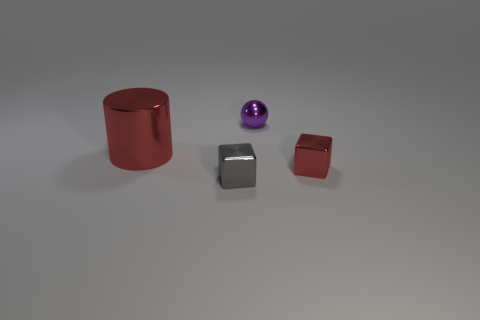Add 2 small yellow balls. How many objects exist? 6 Subtract all spheres. How many objects are left? 3 Add 4 large red things. How many large red things exist? 5 Subtract 0 blue blocks. How many objects are left? 4 Subtract all tiny purple objects. Subtract all tiny red shiny cubes. How many objects are left? 2 Add 1 purple metallic things. How many purple metallic things are left? 2 